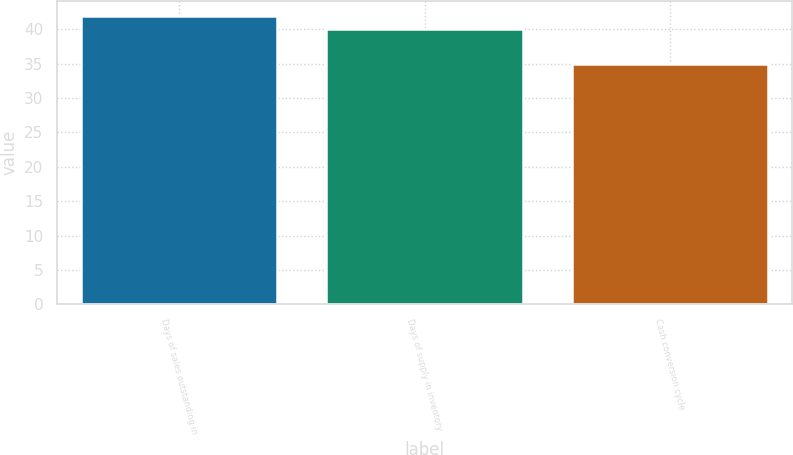Convert chart to OTSL. <chart><loc_0><loc_0><loc_500><loc_500><bar_chart><fcel>Days of sales outstanding in<fcel>Days of supply in inventory<fcel>Cash conversion cycle<nl><fcel>42<fcel>40<fcel>35<nl></chart> 